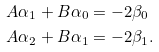Convert formula to latex. <formula><loc_0><loc_0><loc_500><loc_500>A \alpha _ { 1 } + B \alpha _ { 0 } & = - 2 \beta _ { 0 } \\ A \alpha _ { 2 } + B \alpha _ { 1 } & = - 2 \beta _ { 1 } .</formula> 